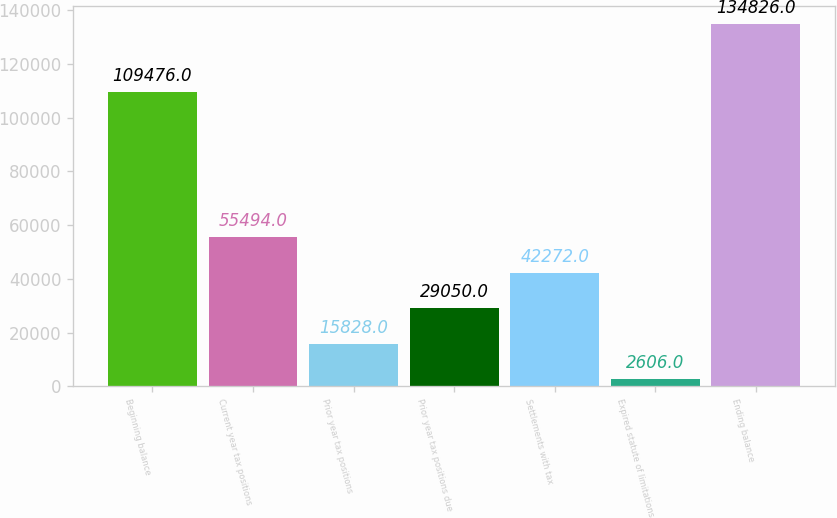Convert chart to OTSL. <chart><loc_0><loc_0><loc_500><loc_500><bar_chart><fcel>Beginning balance<fcel>Current year tax positions<fcel>Prior year tax positions<fcel>Prior year tax positions due<fcel>Settlements with tax<fcel>Expired statute of limitations<fcel>Ending balance<nl><fcel>109476<fcel>55494<fcel>15828<fcel>29050<fcel>42272<fcel>2606<fcel>134826<nl></chart> 